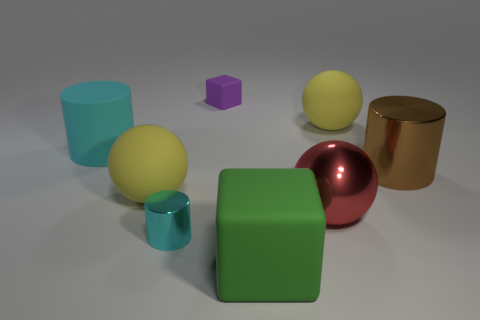Subtract all large yellow balls. How many balls are left? 1 Add 1 purple objects. How many objects exist? 9 Subtract all red balls. Subtract all gray cylinders. How many balls are left? 2 Add 3 large cyan things. How many large cyan things are left? 4 Add 1 tiny metal objects. How many tiny metal objects exist? 2 Subtract all yellow spheres. How many spheres are left? 1 Subtract 1 cyan cylinders. How many objects are left? 7 Subtract all cubes. How many objects are left? 6 Subtract 1 cubes. How many cubes are left? 1 Subtract all green cylinders. How many yellow spheres are left? 2 